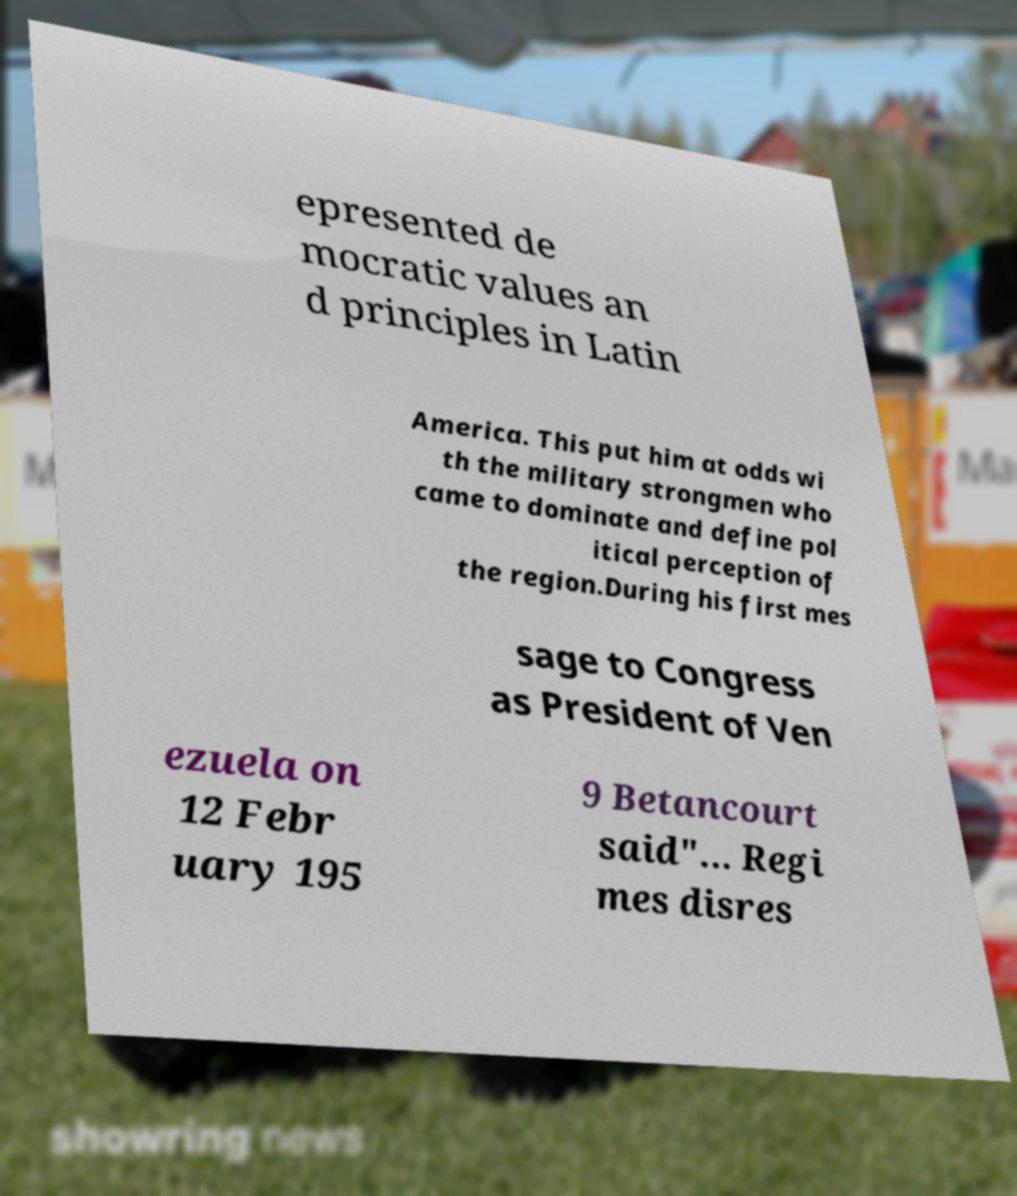What messages or text are displayed in this image? I need them in a readable, typed format. epresented de mocratic values an d principles in Latin America. This put him at odds wi th the military strongmen who came to dominate and define pol itical perception of the region.During his first mes sage to Congress as President of Ven ezuela on 12 Febr uary 195 9 Betancourt said"... Regi mes disres 